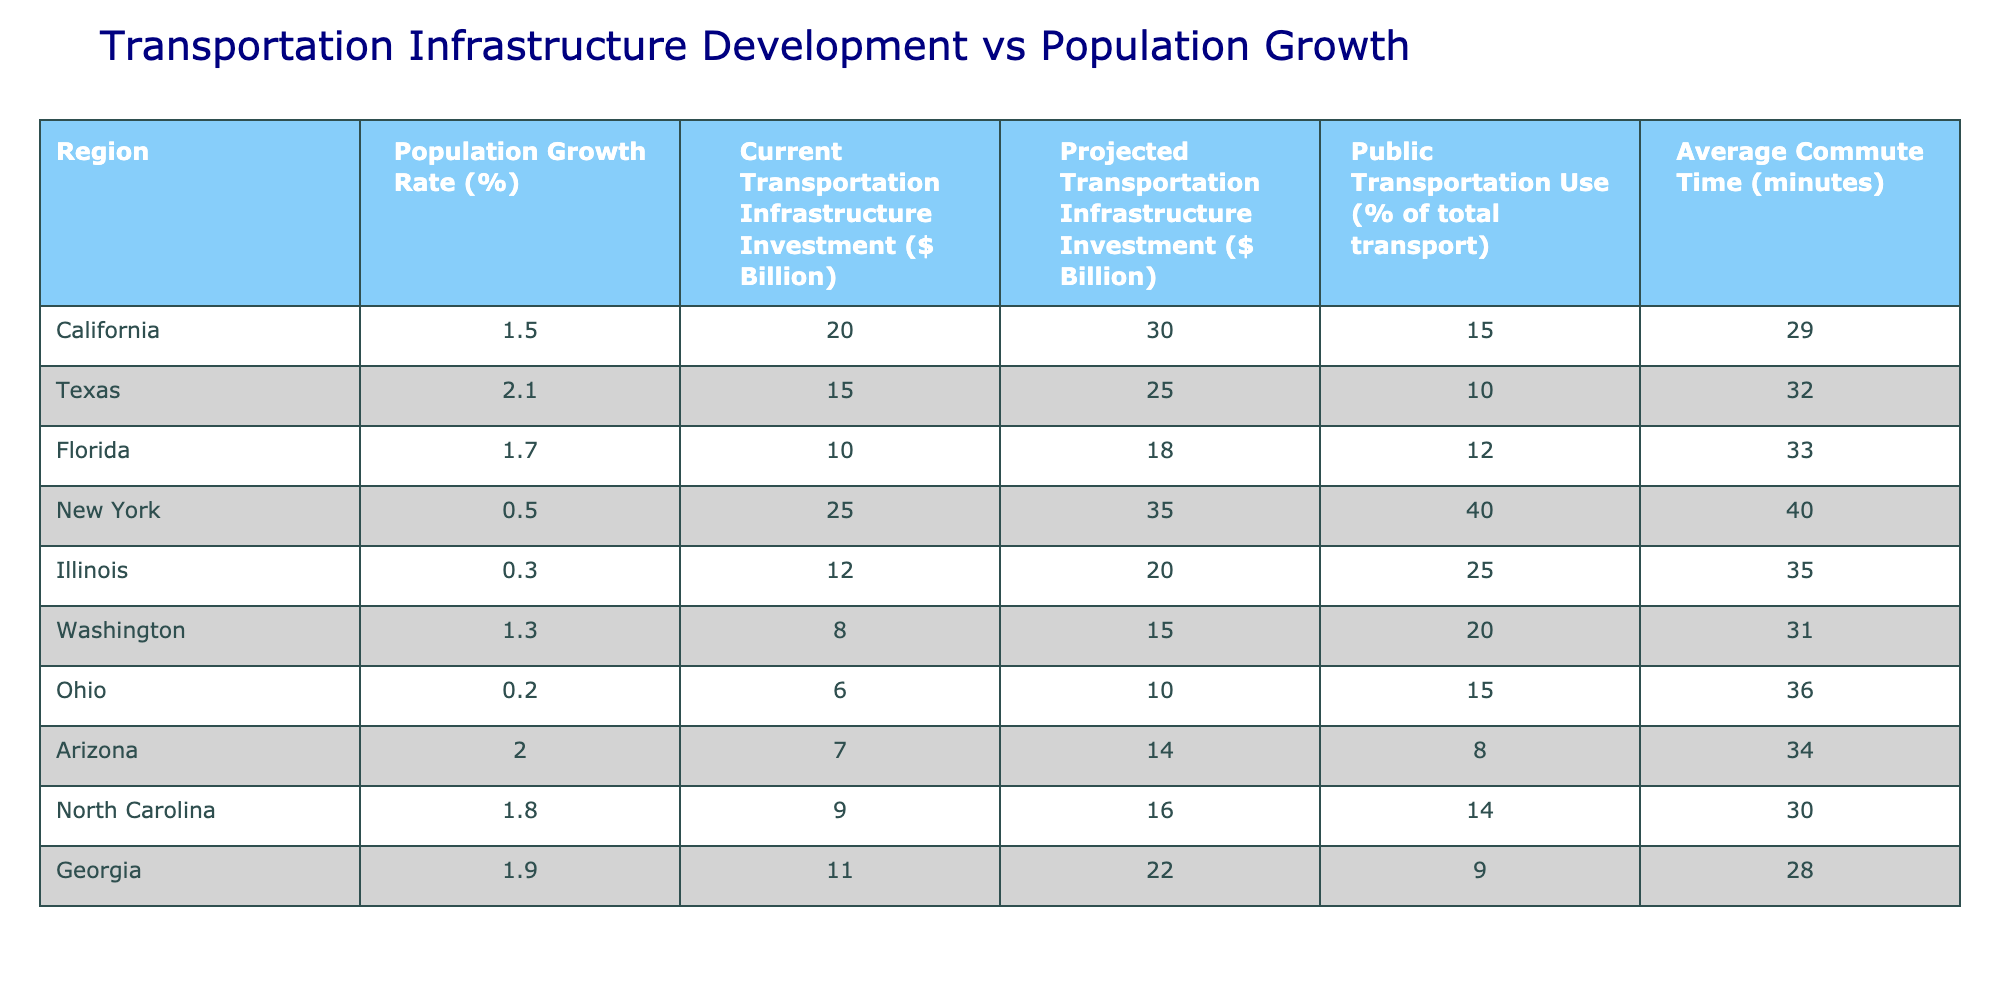What is the population growth rate of Texas? From the table, the population growth rate for Texas is listed directly in the corresponding row under the "Population Growth Rate (%)" column.
Answer: 2.1 Which region has the highest projected transportation infrastructure investment? By examining the "Projected Transportation Infrastructure Investment ($ Billion)" column, the highest value is found in New York with 35 billion dollars.
Answer: New York What is the average commute time for regions with a population growth rate greater than 1.5%? The regions with a growth rate greater than 1.5% are Texas (2.1), Florida (1.7), Arizona (2.0), North Carolina (1.8), and Georgia (1.9). Their commute times are 32, 33, 34, 30, and 28 minutes, respectively. First, sum these commute times: 32 + 33 + 34 + 30 + 28 = 157. Next, divide by the number of regions: 157 / 5 = 31.4 minutes.
Answer: 31.4 minutes Is it true that Ohio has a higher percentage of public transportation use than Florida? Looking at the "Public Transportation Use (% of total transport)" column, Ohio has 15% while Florida has 12%. Since 15% is greater than 12%, the statement is true.
Answer: Yes How much more is projected transportation infrastructure investment in California compared to Washington? The projected transportation investments are 30 billion dollars for California and 15 billion dollars for Washington. Subtracting these amounts gives: 30 - 15 = 15 billion dollars more in California.
Answer: 15 billion dollars 